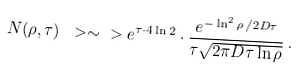Convert formula to latex. <formula><loc_0><loc_0><loc_500><loc_500>N ( \rho , \tau ) \ > \sim \ > e ^ { \tau \cdot 4 \ln 2 } \cdot \frac { e ^ { - \ln ^ { 2 } \rho \, / { 2 D \tau } } } { \tau \sqrt { 2 \pi D \tau \ln \rho } } \, .</formula> 